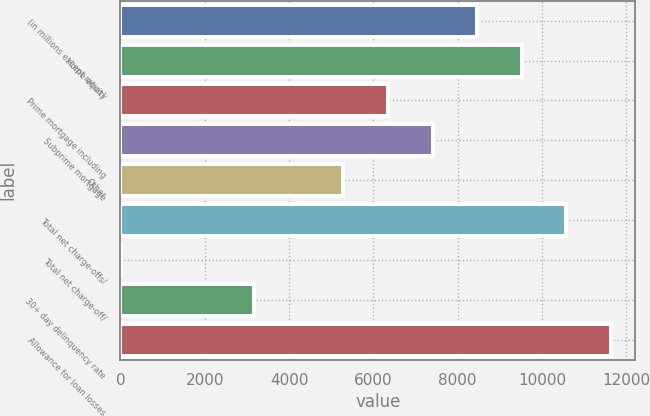Convert chart. <chart><loc_0><loc_0><loc_500><loc_500><bar_chart><fcel>(in millions except ratios)<fcel>Home equity<fcel>Prime mortgage including<fcel>Subprime mortgage<fcel>Other<fcel>Total net charge-offs/<fcel>Total net charge-off/<fcel>30+ day delinquency rate<fcel>Allowance for loan losses<nl><fcel>8463.55<fcel>9521.27<fcel>6348.11<fcel>7405.83<fcel>5290.39<fcel>10579<fcel>1.79<fcel>3174.95<fcel>11636.7<nl></chart> 